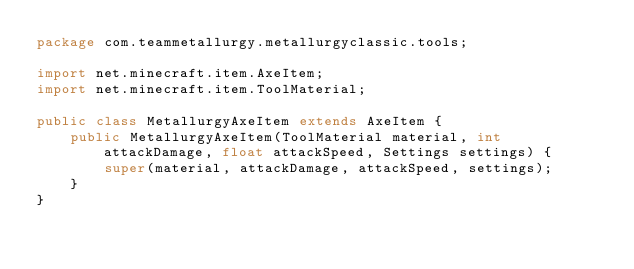Convert code to text. <code><loc_0><loc_0><loc_500><loc_500><_Java_>package com.teammetallurgy.metallurgyclassic.tools;

import net.minecraft.item.AxeItem;
import net.minecraft.item.ToolMaterial;

public class MetallurgyAxeItem extends AxeItem {
    public MetallurgyAxeItem(ToolMaterial material, int attackDamage, float attackSpeed, Settings settings) {
        super(material, attackDamage, attackSpeed, settings);
    }
}
</code> 